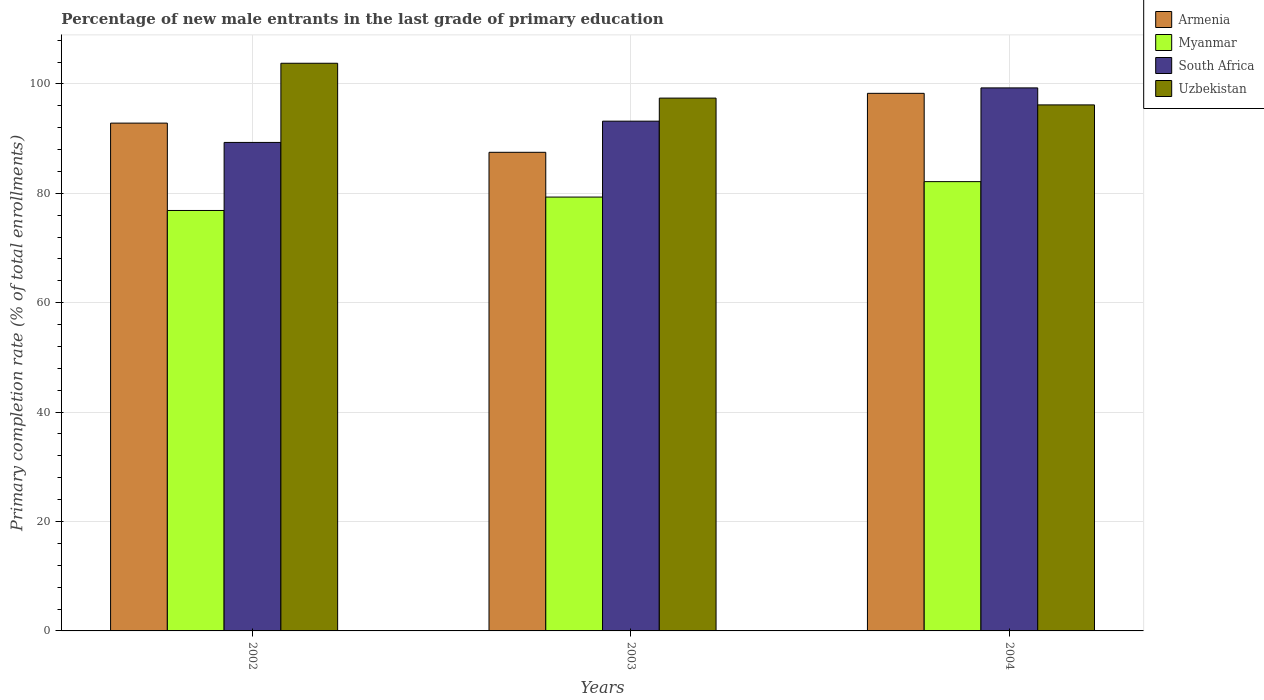How many different coloured bars are there?
Offer a terse response. 4. Are the number of bars per tick equal to the number of legend labels?
Your answer should be compact. Yes. How many bars are there on the 1st tick from the right?
Your answer should be compact. 4. In how many cases, is the number of bars for a given year not equal to the number of legend labels?
Offer a very short reply. 0. What is the percentage of new male entrants in Uzbekistan in 2004?
Your response must be concise. 96.16. Across all years, what is the maximum percentage of new male entrants in Myanmar?
Provide a short and direct response. 82.13. Across all years, what is the minimum percentage of new male entrants in Armenia?
Make the answer very short. 87.49. In which year was the percentage of new male entrants in Uzbekistan maximum?
Offer a very short reply. 2002. In which year was the percentage of new male entrants in South Africa minimum?
Give a very brief answer. 2002. What is the total percentage of new male entrants in Myanmar in the graph?
Your response must be concise. 238.3. What is the difference between the percentage of new male entrants in South Africa in 2002 and that in 2003?
Ensure brevity in your answer.  -3.89. What is the difference between the percentage of new male entrants in Myanmar in 2002 and the percentage of new male entrants in Armenia in 2004?
Offer a terse response. -21.41. What is the average percentage of new male entrants in South Africa per year?
Ensure brevity in your answer.  93.92. In the year 2003, what is the difference between the percentage of new male entrants in Uzbekistan and percentage of new male entrants in South Africa?
Your response must be concise. 4.22. What is the ratio of the percentage of new male entrants in South Africa in 2003 to that in 2004?
Your answer should be compact. 0.94. Is the percentage of new male entrants in South Africa in 2002 less than that in 2003?
Provide a short and direct response. Yes. Is the difference between the percentage of new male entrants in Uzbekistan in 2002 and 2004 greater than the difference between the percentage of new male entrants in South Africa in 2002 and 2004?
Provide a short and direct response. Yes. What is the difference between the highest and the second highest percentage of new male entrants in Myanmar?
Provide a succinct answer. 2.82. What is the difference between the highest and the lowest percentage of new male entrants in Armenia?
Give a very brief answer. 10.78. In how many years, is the percentage of new male entrants in South Africa greater than the average percentage of new male entrants in South Africa taken over all years?
Provide a short and direct response. 1. What does the 3rd bar from the left in 2002 represents?
Ensure brevity in your answer.  South Africa. What does the 3rd bar from the right in 2004 represents?
Offer a terse response. Myanmar. How many bars are there?
Ensure brevity in your answer.  12. How many years are there in the graph?
Offer a terse response. 3. What is the difference between two consecutive major ticks on the Y-axis?
Offer a terse response. 20. Does the graph contain grids?
Your response must be concise. Yes. What is the title of the graph?
Ensure brevity in your answer.  Percentage of new male entrants in the last grade of primary education. What is the label or title of the X-axis?
Give a very brief answer. Years. What is the label or title of the Y-axis?
Offer a very short reply. Primary completion rate (% of total enrollments). What is the Primary completion rate (% of total enrollments) of Armenia in 2002?
Make the answer very short. 92.83. What is the Primary completion rate (% of total enrollments) in Myanmar in 2002?
Keep it short and to the point. 76.86. What is the Primary completion rate (% of total enrollments) of South Africa in 2002?
Make the answer very short. 89.3. What is the Primary completion rate (% of total enrollments) in Uzbekistan in 2002?
Make the answer very short. 103.77. What is the Primary completion rate (% of total enrollments) of Armenia in 2003?
Your answer should be very brief. 87.49. What is the Primary completion rate (% of total enrollments) of Myanmar in 2003?
Your response must be concise. 79.31. What is the Primary completion rate (% of total enrollments) in South Africa in 2003?
Offer a very short reply. 93.18. What is the Primary completion rate (% of total enrollments) in Uzbekistan in 2003?
Keep it short and to the point. 97.4. What is the Primary completion rate (% of total enrollments) of Armenia in 2004?
Offer a very short reply. 98.27. What is the Primary completion rate (% of total enrollments) of Myanmar in 2004?
Your answer should be compact. 82.13. What is the Primary completion rate (% of total enrollments) of South Africa in 2004?
Ensure brevity in your answer.  99.27. What is the Primary completion rate (% of total enrollments) of Uzbekistan in 2004?
Make the answer very short. 96.16. Across all years, what is the maximum Primary completion rate (% of total enrollments) in Armenia?
Your response must be concise. 98.27. Across all years, what is the maximum Primary completion rate (% of total enrollments) in Myanmar?
Ensure brevity in your answer.  82.13. Across all years, what is the maximum Primary completion rate (% of total enrollments) of South Africa?
Give a very brief answer. 99.27. Across all years, what is the maximum Primary completion rate (% of total enrollments) of Uzbekistan?
Offer a terse response. 103.77. Across all years, what is the minimum Primary completion rate (% of total enrollments) in Armenia?
Make the answer very short. 87.49. Across all years, what is the minimum Primary completion rate (% of total enrollments) of Myanmar?
Your response must be concise. 76.86. Across all years, what is the minimum Primary completion rate (% of total enrollments) of South Africa?
Give a very brief answer. 89.3. Across all years, what is the minimum Primary completion rate (% of total enrollments) of Uzbekistan?
Your response must be concise. 96.16. What is the total Primary completion rate (% of total enrollments) in Armenia in the graph?
Your answer should be compact. 278.6. What is the total Primary completion rate (% of total enrollments) of Myanmar in the graph?
Offer a terse response. 238.3. What is the total Primary completion rate (% of total enrollments) of South Africa in the graph?
Offer a very short reply. 281.75. What is the total Primary completion rate (% of total enrollments) of Uzbekistan in the graph?
Your response must be concise. 297.33. What is the difference between the Primary completion rate (% of total enrollments) in Armenia in 2002 and that in 2003?
Your answer should be compact. 5.34. What is the difference between the Primary completion rate (% of total enrollments) of Myanmar in 2002 and that in 2003?
Ensure brevity in your answer.  -2.45. What is the difference between the Primary completion rate (% of total enrollments) in South Africa in 2002 and that in 2003?
Provide a succinct answer. -3.89. What is the difference between the Primary completion rate (% of total enrollments) in Uzbekistan in 2002 and that in 2003?
Make the answer very short. 6.37. What is the difference between the Primary completion rate (% of total enrollments) in Armenia in 2002 and that in 2004?
Your answer should be very brief. -5.44. What is the difference between the Primary completion rate (% of total enrollments) in Myanmar in 2002 and that in 2004?
Your answer should be very brief. -5.27. What is the difference between the Primary completion rate (% of total enrollments) of South Africa in 2002 and that in 2004?
Provide a succinct answer. -9.97. What is the difference between the Primary completion rate (% of total enrollments) of Uzbekistan in 2002 and that in 2004?
Give a very brief answer. 7.61. What is the difference between the Primary completion rate (% of total enrollments) of Armenia in 2003 and that in 2004?
Your answer should be very brief. -10.78. What is the difference between the Primary completion rate (% of total enrollments) in Myanmar in 2003 and that in 2004?
Give a very brief answer. -2.82. What is the difference between the Primary completion rate (% of total enrollments) of South Africa in 2003 and that in 2004?
Ensure brevity in your answer.  -6.08. What is the difference between the Primary completion rate (% of total enrollments) in Uzbekistan in 2003 and that in 2004?
Provide a succinct answer. 1.24. What is the difference between the Primary completion rate (% of total enrollments) in Armenia in 2002 and the Primary completion rate (% of total enrollments) in Myanmar in 2003?
Your response must be concise. 13.52. What is the difference between the Primary completion rate (% of total enrollments) of Armenia in 2002 and the Primary completion rate (% of total enrollments) of South Africa in 2003?
Provide a succinct answer. -0.35. What is the difference between the Primary completion rate (% of total enrollments) of Armenia in 2002 and the Primary completion rate (% of total enrollments) of Uzbekistan in 2003?
Ensure brevity in your answer.  -4.57. What is the difference between the Primary completion rate (% of total enrollments) in Myanmar in 2002 and the Primary completion rate (% of total enrollments) in South Africa in 2003?
Your response must be concise. -16.32. What is the difference between the Primary completion rate (% of total enrollments) in Myanmar in 2002 and the Primary completion rate (% of total enrollments) in Uzbekistan in 2003?
Your answer should be very brief. -20.54. What is the difference between the Primary completion rate (% of total enrollments) of South Africa in 2002 and the Primary completion rate (% of total enrollments) of Uzbekistan in 2003?
Offer a very short reply. -8.1. What is the difference between the Primary completion rate (% of total enrollments) of Armenia in 2002 and the Primary completion rate (% of total enrollments) of Myanmar in 2004?
Offer a terse response. 10.7. What is the difference between the Primary completion rate (% of total enrollments) in Armenia in 2002 and the Primary completion rate (% of total enrollments) in South Africa in 2004?
Keep it short and to the point. -6.44. What is the difference between the Primary completion rate (% of total enrollments) in Armenia in 2002 and the Primary completion rate (% of total enrollments) in Uzbekistan in 2004?
Provide a short and direct response. -3.33. What is the difference between the Primary completion rate (% of total enrollments) in Myanmar in 2002 and the Primary completion rate (% of total enrollments) in South Africa in 2004?
Make the answer very short. -22.41. What is the difference between the Primary completion rate (% of total enrollments) in Myanmar in 2002 and the Primary completion rate (% of total enrollments) in Uzbekistan in 2004?
Your response must be concise. -19.3. What is the difference between the Primary completion rate (% of total enrollments) in South Africa in 2002 and the Primary completion rate (% of total enrollments) in Uzbekistan in 2004?
Keep it short and to the point. -6.86. What is the difference between the Primary completion rate (% of total enrollments) in Armenia in 2003 and the Primary completion rate (% of total enrollments) in Myanmar in 2004?
Your answer should be very brief. 5.36. What is the difference between the Primary completion rate (% of total enrollments) of Armenia in 2003 and the Primary completion rate (% of total enrollments) of South Africa in 2004?
Your response must be concise. -11.77. What is the difference between the Primary completion rate (% of total enrollments) of Armenia in 2003 and the Primary completion rate (% of total enrollments) of Uzbekistan in 2004?
Your response must be concise. -8.67. What is the difference between the Primary completion rate (% of total enrollments) of Myanmar in 2003 and the Primary completion rate (% of total enrollments) of South Africa in 2004?
Your answer should be compact. -19.96. What is the difference between the Primary completion rate (% of total enrollments) of Myanmar in 2003 and the Primary completion rate (% of total enrollments) of Uzbekistan in 2004?
Make the answer very short. -16.85. What is the difference between the Primary completion rate (% of total enrollments) in South Africa in 2003 and the Primary completion rate (% of total enrollments) in Uzbekistan in 2004?
Your answer should be very brief. -2.98. What is the average Primary completion rate (% of total enrollments) in Armenia per year?
Make the answer very short. 92.87. What is the average Primary completion rate (% of total enrollments) of Myanmar per year?
Provide a succinct answer. 79.43. What is the average Primary completion rate (% of total enrollments) in South Africa per year?
Your response must be concise. 93.92. What is the average Primary completion rate (% of total enrollments) in Uzbekistan per year?
Ensure brevity in your answer.  99.11. In the year 2002, what is the difference between the Primary completion rate (% of total enrollments) of Armenia and Primary completion rate (% of total enrollments) of Myanmar?
Keep it short and to the point. 15.97. In the year 2002, what is the difference between the Primary completion rate (% of total enrollments) in Armenia and Primary completion rate (% of total enrollments) in South Africa?
Ensure brevity in your answer.  3.53. In the year 2002, what is the difference between the Primary completion rate (% of total enrollments) in Armenia and Primary completion rate (% of total enrollments) in Uzbekistan?
Your response must be concise. -10.94. In the year 2002, what is the difference between the Primary completion rate (% of total enrollments) in Myanmar and Primary completion rate (% of total enrollments) in South Africa?
Your answer should be compact. -12.44. In the year 2002, what is the difference between the Primary completion rate (% of total enrollments) of Myanmar and Primary completion rate (% of total enrollments) of Uzbekistan?
Offer a very short reply. -26.91. In the year 2002, what is the difference between the Primary completion rate (% of total enrollments) of South Africa and Primary completion rate (% of total enrollments) of Uzbekistan?
Provide a succinct answer. -14.47. In the year 2003, what is the difference between the Primary completion rate (% of total enrollments) of Armenia and Primary completion rate (% of total enrollments) of Myanmar?
Provide a short and direct response. 8.18. In the year 2003, what is the difference between the Primary completion rate (% of total enrollments) in Armenia and Primary completion rate (% of total enrollments) in South Africa?
Keep it short and to the point. -5.69. In the year 2003, what is the difference between the Primary completion rate (% of total enrollments) in Armenia and Primary completion rate (% of total enrollments) in Uzbekistan?
Your answer should be very brief. -9.91. In the year 2003, what is the difference between the Primary completion rate (% of total enrollments) in Myanmar and Primary completion rate (% of total enrollments) in South Africa?
Ensure brevity in your answer.  -13.88. In the year 2003, what is the difference between the Primary completion rate (% of total enrollments) in Myanmar and Primary completion rate (% of total enrollments) in Uzbekistan?
Your answer should be very brief. -18.09. In the year 2003, what is the difference between the Primary completion rate (% of total enrollments) of South Africa and Primary completion rate (% of total enrollments) of Uzbekistan?
Keep it short and to the point. -4.22. In the year 2004, what is the difference between the Primary completion rate (% of total enrollments) of Armenia and Primary completion rate (% of total enrollments) of Myanmar?
Your answer should be very brief. 16.14. In the year 2004, what is the difference between the Primary completion rate (% of total enrollments) in Armenia and Primary completion rate (% of total enrollments) in South Africa?
Ensure brevity in your answer.  -0.99. In the year 2004, what is the difference between the Primary completion rate (% of total enrollments) of Armenia and Primary completion rate (% of total enrollments) of Uzbekistan?
Your answer should be very brief. 2.11. In the year 2004, what is the difference between the Primary completion rate (% of total enrollments) in Myanmar and Primary completion rate (% of total enrollments) in South Africa?
Offer a very short reply. -17.14. In the year 2004, what is the difference between the Primary completion rate (% of total enrollments) in Myanmar and Primary completion rate (% of total enrollments) in Uzbekistan?
Your answer should be very brief. -14.03. In the year 2004, what is the difference between the Primary completion rate (% of total enrollments) of South Africa and Primary completion rate (% of total enrollments) of Uzbekistan?
Offer a terse response. 3.11. What is the ratio of the Primary completion rate (% of total enrollments) of Armenia in 2002 to that in 2003?
Ensure brevity in your answer.  1.06. What is the ratio of the Primary completion rate (% of total enrollments) of Myanmar in 2002 to that in 2003?
Ensure brevity in your answer.  0.97. What is the ratio of the Primary completion rate (% of total enrollments) of Uzbekistan in 2002 to that in 2003?
Offer a very short reply. 1.07. What is the ratio of the Primary completion rate (% of total enrollments) of Armenia in 2002 to that in 2004?
Keep it short and to the point. 0.94. What is the ratio of the Primary completion rate (% of total enrollments) in Myanmar in 2002 to that in 2004?
Your answer should be very brief. 0.94. What is the ratio of the Primary completion rate (% of total enrollments) in South Africa in 2002 to that in 2004?
Ensure brevity in your answer.  0.9. What is the ratio of the Primary completion rate (% of total enrollments) in Uzbekistan in 2002 to that in 2004?
Provide a short and direct response. 1.08. What is the ratio of the Primary completion rate (% of total enrollments) in Armenia in 2003 to that in 2004?
Ensure brevity in your answer.  0.89. What is the ratio of the Primary completion rate (% of total enrollments) of Myanmar in 2003 to that in 2004?
Provide a succinct answer. 0.97. What is the ratio of the Primary completion rate (% of total enrollments) in South Africa in 2003 to that in 2004?
Your answer should be very brief. 0.94. What is the ratio of the Primary completion rate (% of total enrollments) of Uzbekistan in 2003 to that in 2004?
Give a very brief answer. 1.01. What is the difference between the highest and the second highest Primary completion rate (% of total enrollments) in Armenia?
Keep it short and to the point. 5.44. What is the difference between the highest and the second highest Primary completion rate (% of total enrollments) of Myanmar?
Make the answer very short. 2.82. What is the difference between the highest and the second highest Primary completion rate (% of total enrollments) in South Africa?
Your response must be concise. 6.08. What is the difference between the highest and the second highest Primary completion rate (% of total enrollments) of Uzbekistan?
Offer a terse response. 6.37. What is the difference between the highest and the lowest Primary completion rate (% of total enrollments) of Armenia?
Provide a succinct answer. 10.78. What is the difference between the highest and the lowest Primary completion rate (% of total enrollments) of Myanmar?
Provide a succinct answer. 5.27. What is the difference between the highest and the lowest Primary completion rate (% of total enrollments) of South Africa?
Keep it short and to the point. 9.97. What is the difference between the highest and the lowest Primary completion rate (% of total enrollments) of Uzbekistan?
Offer a very short reply. 7.61. 